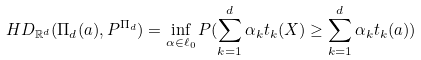<formula> <loc_0><loc_0><loc_500><loc_500>H D _ { \mathbb { R } ^ { d } } ( \Pi _ { d } ( a ) , P ^ { \Pi _ { d } } ) = \inf _ { \alpha \in \ell _ { 0 } } P ( \sum _ { k = 1 } ^ { d } \alpha _ { k } t _ { k } ( X ) \geq \sum _ { k = 1 } ^ { d } \alpha _ { k } t _ { k } ( a ) )</formula> 